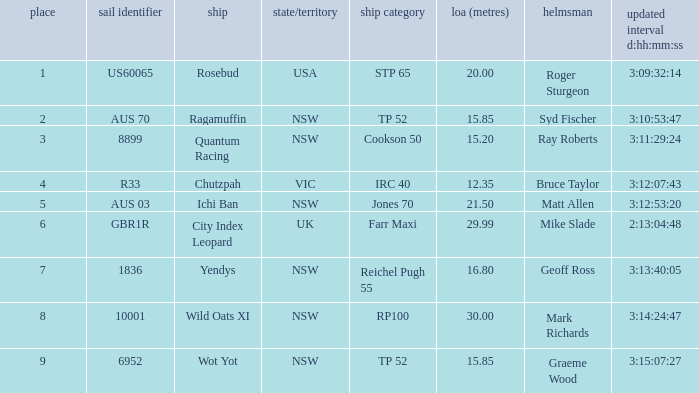Help me parse the entirety of this table. {'header': ['place', 'sail identifier', 'ship', 'state/territory', 'ship category', 'loa (metres)', 'helmsman', 'updated interval d:hh:mm:ss'], 'rows': [['1', 'US60065', 'Rosebud', 'USA', 'STP 65', '20.00', 'Roger Sturgeon', '3:09:32:14'], ['2', 'AUS 70', 'Ragamuffin', 'NSW', 'TP 52', '15.85', 'Syd Fischer', '3:10:53:47'], ['3', '8899', 'Quantum Racing', 'NSW', 'Cookson 50', '15.20', 'Ray Roberts', '3:11:29:24'], ['4', 'R33', 'Chutzpah', 'VIC', 'IRC 40', '12.35', 'Bruce Taylor', '3:12:07:43'], ['5', 'AUS 03', 'Ichi Ban', 'NSW', 'Jones 70', '21.50', 'Matt Allen', '3:12:53:20'], ['6', 'GBR1R', 'City Index Leopard', 'UK', 'Farr Maxi', '29.99', 'Mike Slade', '2:13:04:48'], ['7', '1836', 'Yendys', 'NSW', 'Reichel Pugh 55', '16.80', 'Geoff Ross', '3:13:40:05'], ['8', '10001', 'Wild Oats XI', 'NSW', 'RP100', '30.00', 'Mark Richards', '3:14:24:47'], ['9', '6952', 'Wot Yot', 'NSW', 'TP 52', '15.85', 'Graeme Wood', '3:15:07:27']]} What are all of the states or countries with a corrected time 3:13:40:05? NSW. 